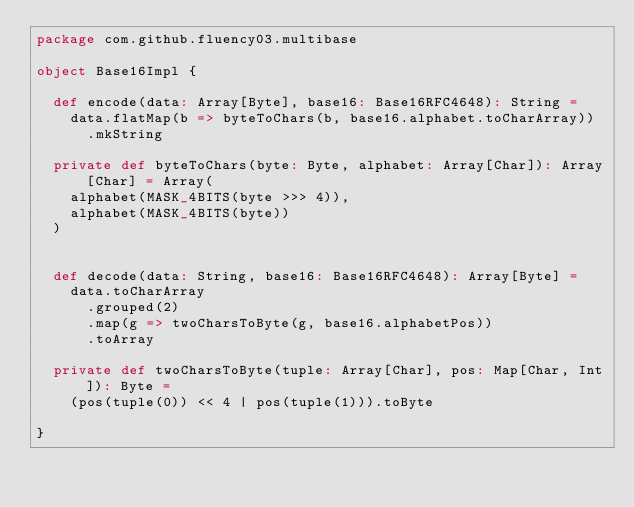<code> <loc_0><loc_0><loc_500><loc_500><_Scala_>package com.github.fluency03.multibase

object Base16Impl {

  def encode(data: Array[Byte], base16: Base16RFC4648): String =
    data.flatMap(b => byteToChars(b, base16.alphabet.toCharArray))
      .mkString

  private def byteToChars(byte: Byte, alphabet: Array[Char]): Array[Char] = Array(
    alphabet(MASK_4BITS(byte >>> 4)),
    alphabet(MASK_4BITS(byte))
  )


  def decode(data: String, base16: Base16RFC4648): Array[Byte] =
    data.toCharArray
      .grouped(2)
      .map(g => twoCharsToByte(g, base16.alphabetPos))
      .toArray

  private def twoCharsToByte(tuple: Array[Char], pos: Map[Char, Int]): Byte =
    (pos(tuple(0)) << 4 | pos(tuple(1))).toByte

}
</code> 